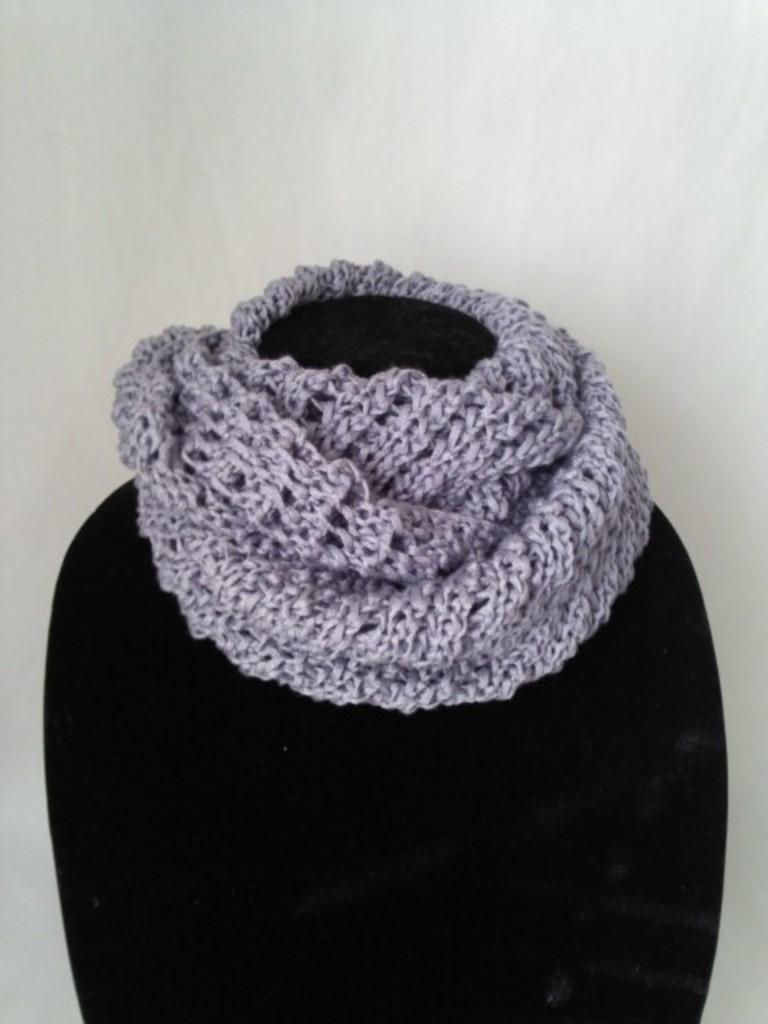Could you give a brief overview of what you see in this image? In this image we can see purple color woolen scarf on the mannequin. We can see white color wall in the background. 